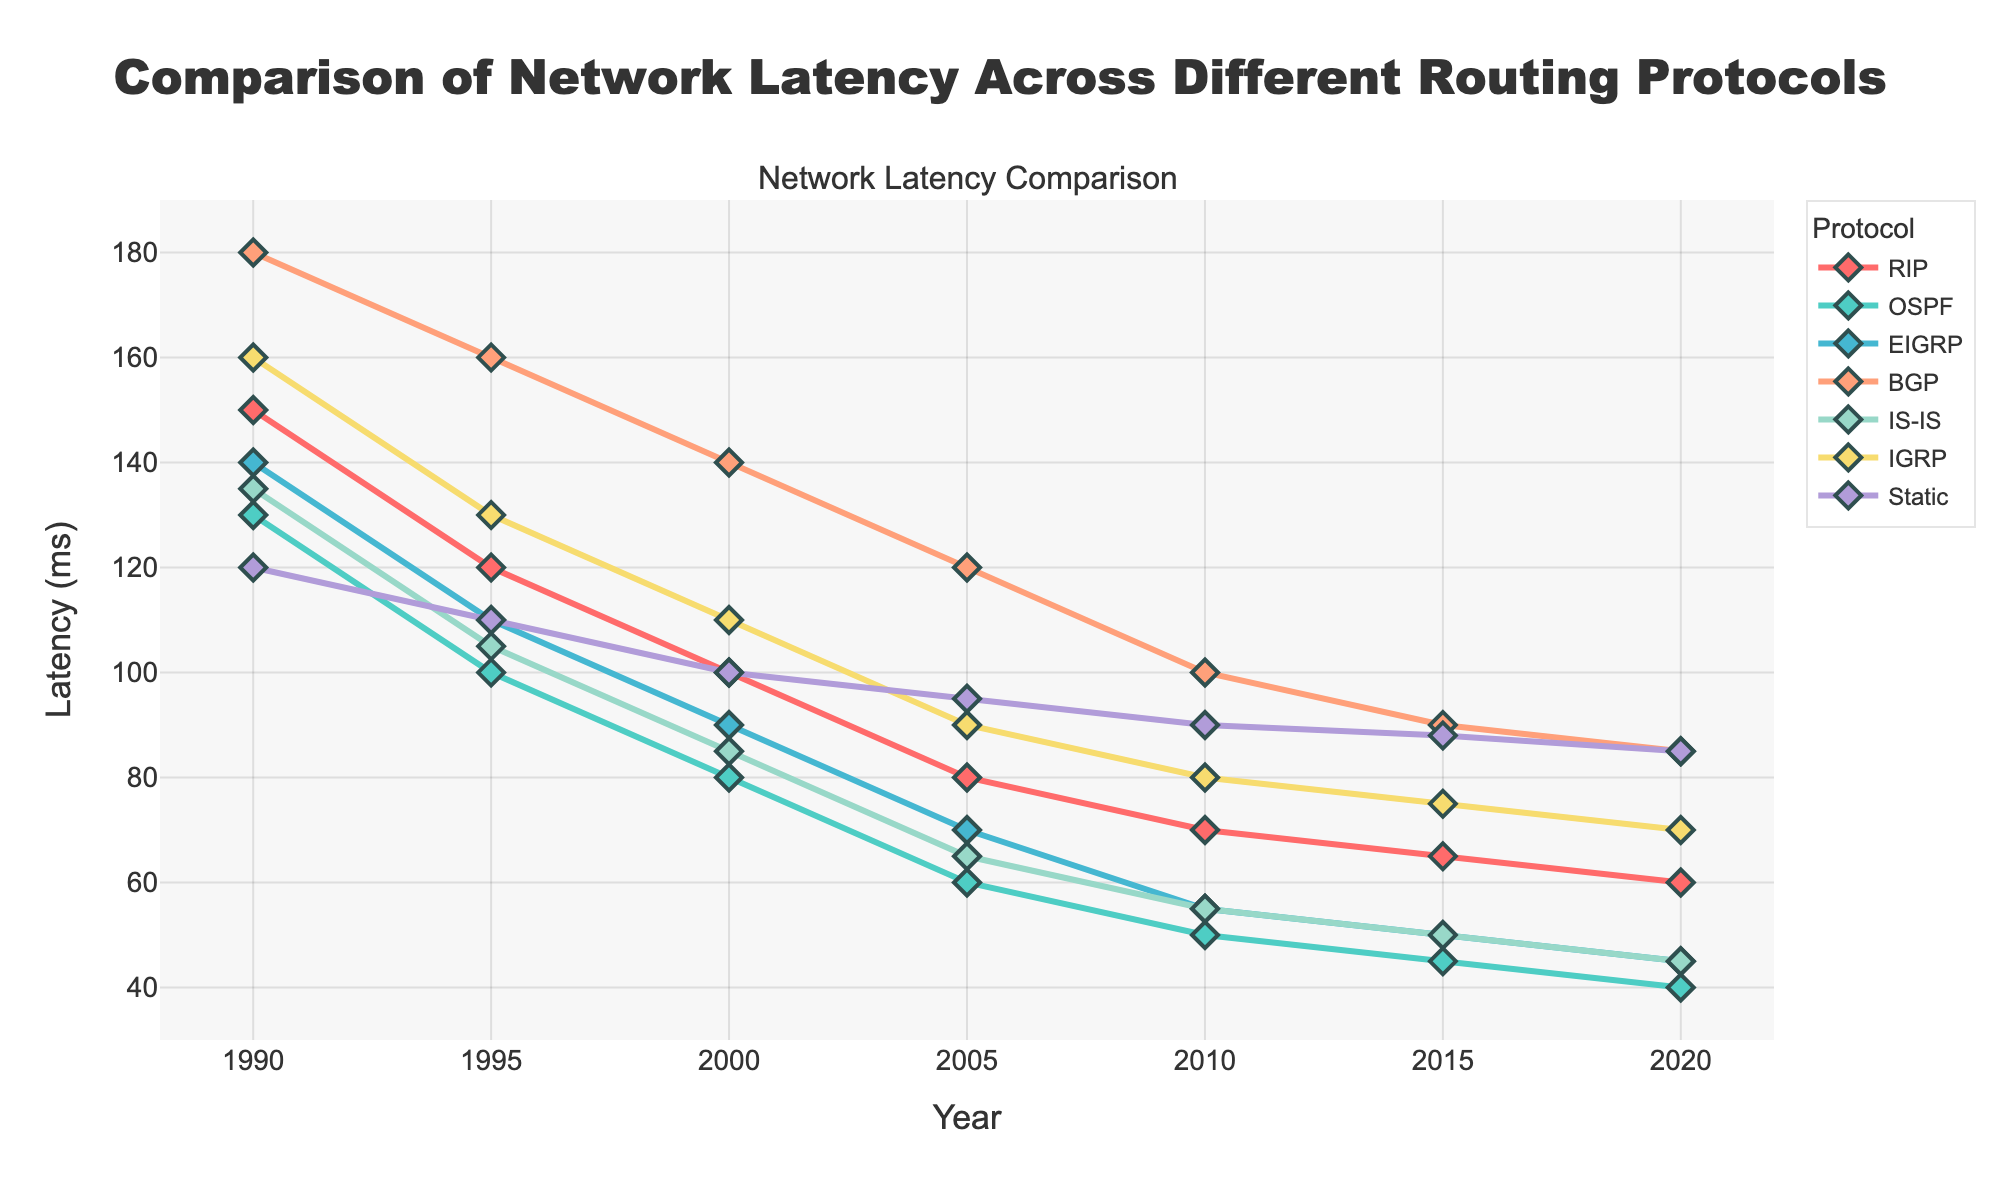What year did the RIP protocol reach a latency of 60 ms? To find the year when the RIP protocol reached a latency of 60 ms, look at the RIP line and trace it to the corresponding year on the x-axis. The data shows that for the RIP protocol, the latency is 60 ms in 2020.
Answer: 2020 Which protocol had the highest latency in 1990? Review the latency values for each protocol in the year 1990. RIP had a latency of 150 ms, OSPF 130 ms, EIGRP 140 ms, BGP 180 ms, IS-IS 135 ms, IGRP 160 ms, and Static 120 ms. BGP, with a latency of 180 ms, had the highest latency.
Answer: BGP How has the latency of the OSPF protocol changed from 1990 to 2020? To determine the change in latency for the OSPF protocol between 1990 and 2020, look at the values for OSPF in these years. The latency decreased from 130 ms in 1990 to 40 ms in 2020. The change is a decrease of 90 ms.
Answer: Decreased by 90 ms Which protocol showed the smallest decrease in latency from 1990 to 2020? Calculate the difference in latency from 1990 to 2020 for each protocol: RIP (150 to 60, a decrease of 90 ms), OSPF (130 to 40, a decrease of 90 ms), EIGRP (140 to 45, a decrease of 95 ms), BGP (180 to 85, a decrease of 95 ms), IS-IS (135 to 45, a decrease of 90 ms), IGRP (160 to 70, a decrease of 90 ms), and Static (120 to 85, a decrease of 35 ms). The smallest decrease is for the Static protocol with a reduction of 35 ms.
Answer: Static What is the average latency of the EIGRP protocol across all years shown? Calculate the average by summing the EIGRP latencies across the years and dividing by the number of years. The values are 140, 110, 90, 70, 55, 50, and 45. Sum these to get 140 + 110 + 90 + 70 + 55 + 50 + 45 = 560. There are 7 years, so the average is 560 / 7 = 80.
Answer: 80 ms In what year did IS-IS have the same latency as EIGRP, and what was it? Trace the IS-IS and EIGRP plots to identify years when their latencies are equal. In 2020, both IS-IS and EIGRP had a latency of 45 ms.
Answer: 2020, 45 ms Which protocol had the second lowest latency in 2010? Check the latencies for all protocols in 2010: RIP (70 ms), OSPF (50 ms), EIGRP (55 ms), BGP (100 ms), IS-IS (55 ms), IGRP (80 ms), and Static (90 ms). The lowest latency was OSPF (50 ms) and the second lowest was IS-IS (55 ms).
Answer: IS-IS What are the two protocols with the closest latency in 2000? Compare the latencies of all protocols in 2000: RIP (100 ms), OSPF (80 ms), EIGRP (90 ms), BGP (140 ms), IS-IS (85 ms), IGRP (110 ms), and Static (100 ms). The smallest difference is between RIP and Static, both of which had a latency of 100 ms.
Answer: RIP and Static How does the latency of BGP in 2015 compare to IGRP in the same year? Look at the latency values for BGP and IGRP in 2015. BGP had a latency of 90 ms, while IGRP had a latency of 75 ms. BGP's latency is higher.
Answer: BGP is higher What is the trend in latency for the Static routing protocol over the years displayed? Trace the Static protocol line from 1990 to 2020. The latency decreases from 120 ms in 1990 to 85 ms in 2020. The trend is generally a slight downward slope, indicating a decrease in latency over time.
Answer: Decreasing 